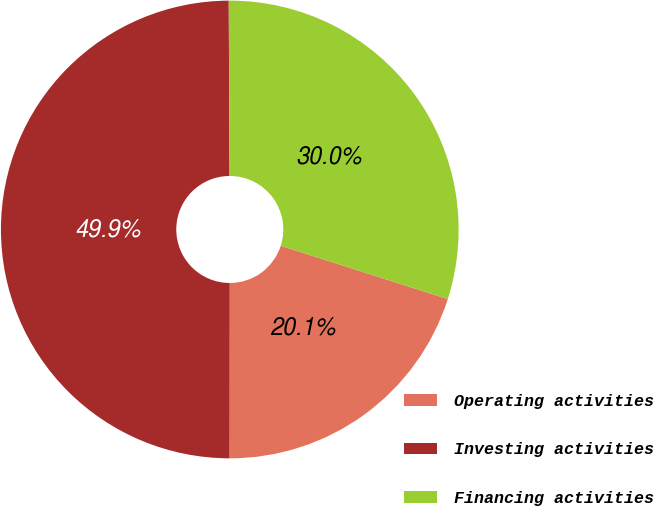<chart> <loc_0><loc_0><loc_500><loc_500><pie_chart><fcel>Operating activities<fcel>Investing activities<fcel>Financing activities<nl><fcel>20.1%<fcel>49.91%<fcel>29.99%<nl></chart> 